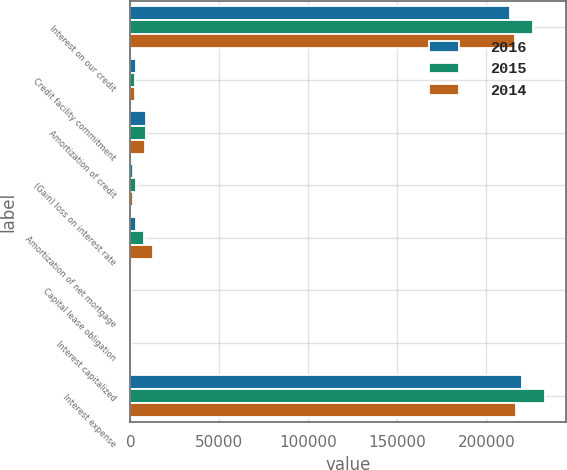<chart> <loc_0><loc_0><loc_500><loc_500><stacked_bar_chart><ecel><fcel>Interest on our credit<fcel>Credit facility commitment<fcel>Amortization of credit<fcel>(Gain) loss on interest rate<fcel>Amortization of net mortgage<fcel>Capital lease obligation<fcel>Interest capitalized<fcel>Interest expense<nl><fcel>2016<fcel>213540<fcel>3050<fcel>8596<fcel>1639<fcel>3414<fcel>310<fcel>469<fcel>219974<nl><fcel>2015<fcel>226207<fcel>2854<fcel>8741<fcel>3043<fcel>7482<fcel>310<fcel>594<fcel>233079<nl><fcel>2014<fcel>215830<fcel>2661<fcel>8219<fcel>1349<fcel>12891<fcel>116<fcel>444<fcel>216366<nl></chart> 